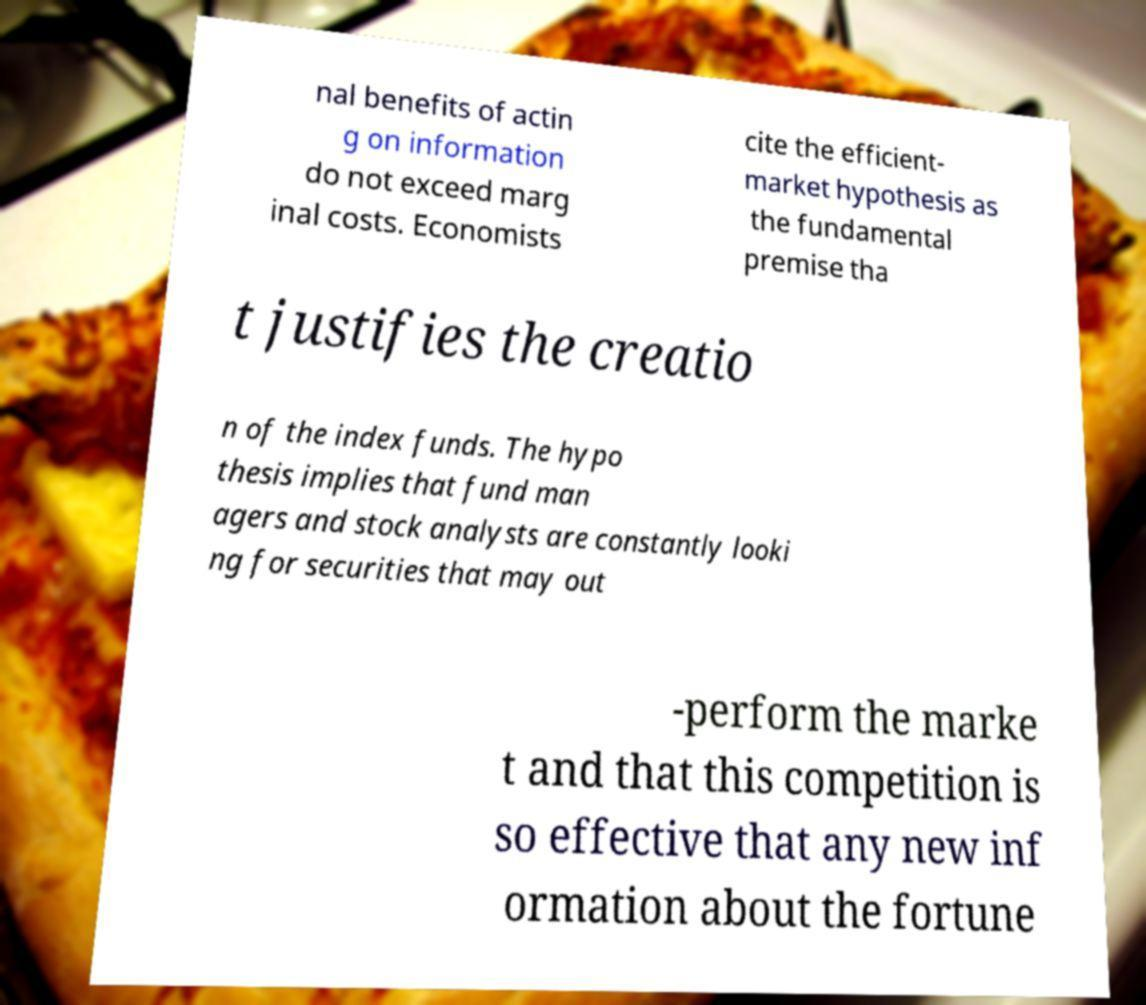Please read and relay the text visible in this image. What does it say? nal benefits of actin g on information do not exceed marg inal costs. Economists cite the efficient- market hypothesis as the fundamental premise tha t justifies the creatio n of the index funds. The hypo thesis implies that fund man agers and stock analysts are constantly looki ng for securities that may out -perform the marke t and that this competition is so effective that any new inf ormation about the fortune 